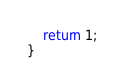Convert code to text. <code><loc_0><loc_0><loc_500><loc_500><_C_>	return 1;
}
</code> 